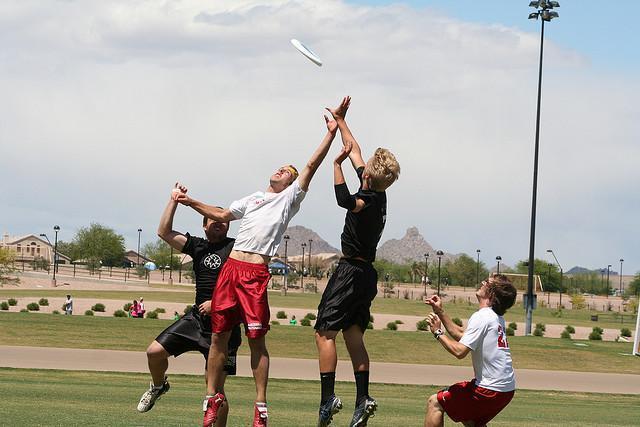How many people are in the picture?
Give a very brief answer. 4. How many cats do you see?
Give a very brief answer. 0. 